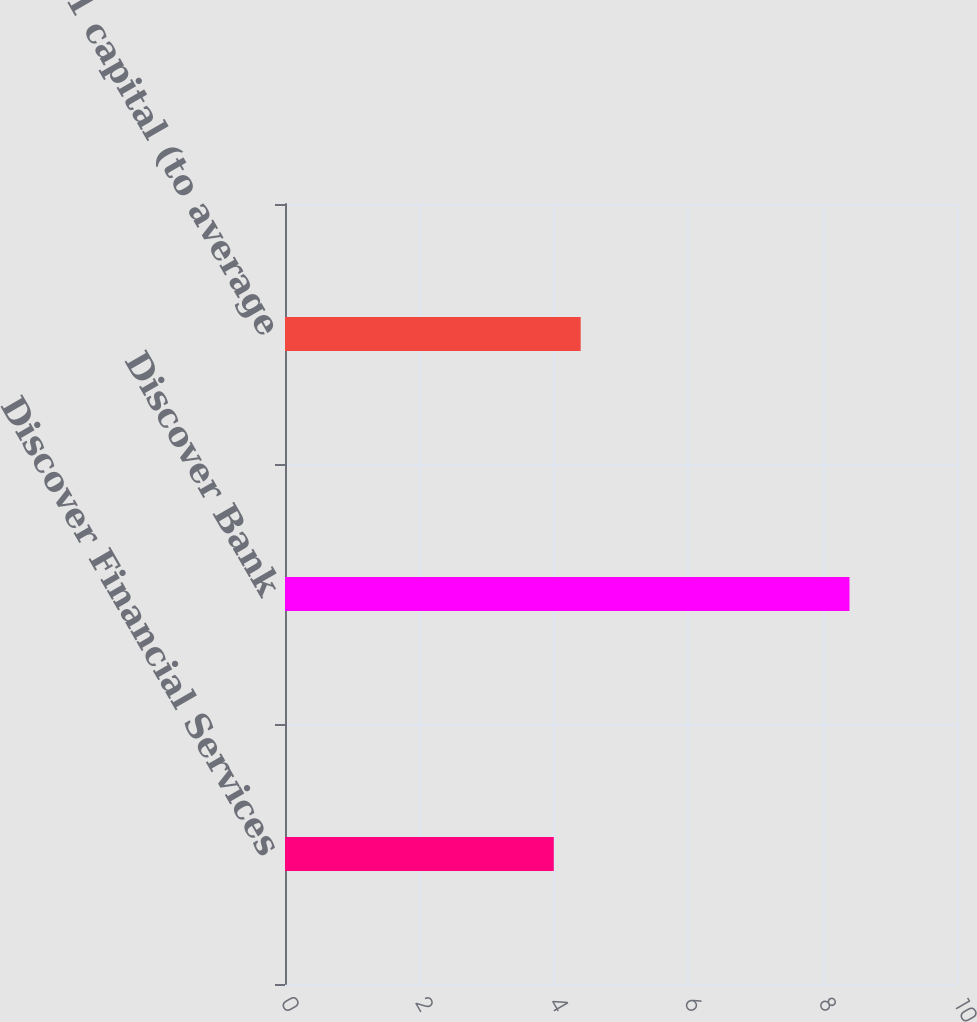Convert chart. <chart><loc_0><loc_0><loc_500><loc_500><bar_chart><fcel>Discover Financial Services<fcel>Discover Bank<fcel>Tier 1 capital (to average<nl><fcel>4<fcel>8.4<fcel>4.4<nl></chart> 